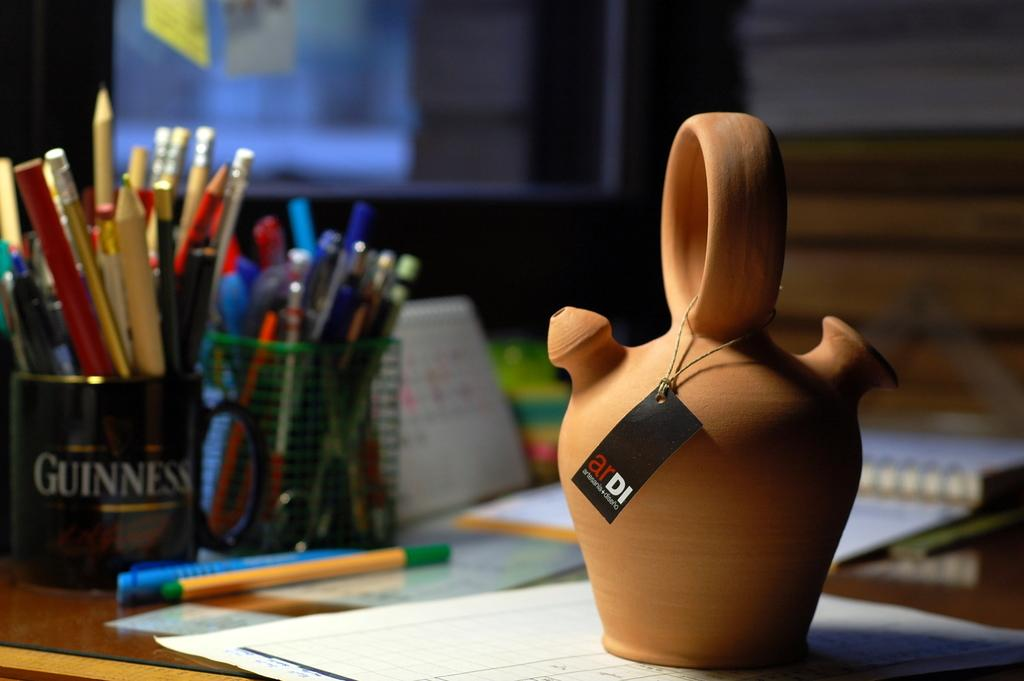<image>
Present a compact description of the photo's key features. a desk with a Guinness mug as a pencil holder 